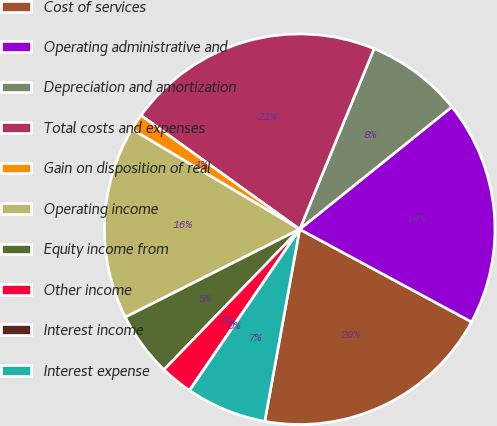Convert chart. <chart><loc_0><loc_0><loc_500><loc_500><pie_chart><fcel>Cost of services<fcel>Operating administrative and<fcel>Depreciation and amortization<fcel>Total costs and expenses<fcel>Gain on disposition of real<fcel>Operating income<fcel>Equity income from<fcel>Other income<fcel>Interest income<fcel>Interest expense<nl><fcel>19.99%<fcel>18.65%<fcel>8.0%<fcel>21.32%<fcel>1.35%<fcel>15.99%<fcel>5.34%<fcel>2.68%<fcel>0.01%<fcel>6.67%<nl></chart> 